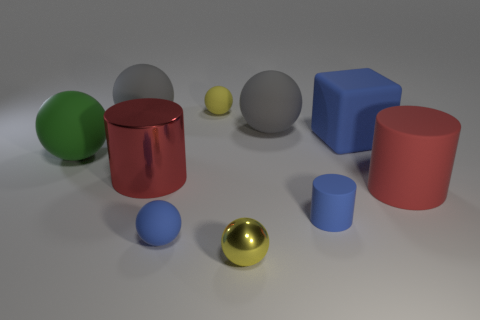Subtract all red cylinders. How many cylinders are left? 1 Subtract all red cylinders. How many cylinders are left? 1 Subtract all balls. How many objects are left? 4 Subtract all purple balls. Subtract all brown cylinders. How many balls are left? 6 Subtract all blue spheres. How many green cylinders are left? 0 Subtract all large red matte cylinders. Subtract all tiny objects. How many objects are left? 5 Add 4 large matte objects. How many large matte objects are left? 9 Add 2 red things. How many red things exist? 4 Subtract 1 red cylinders. How many objects are left? 9 Subtract 1 cylinders. How many cylinders are left? 2 